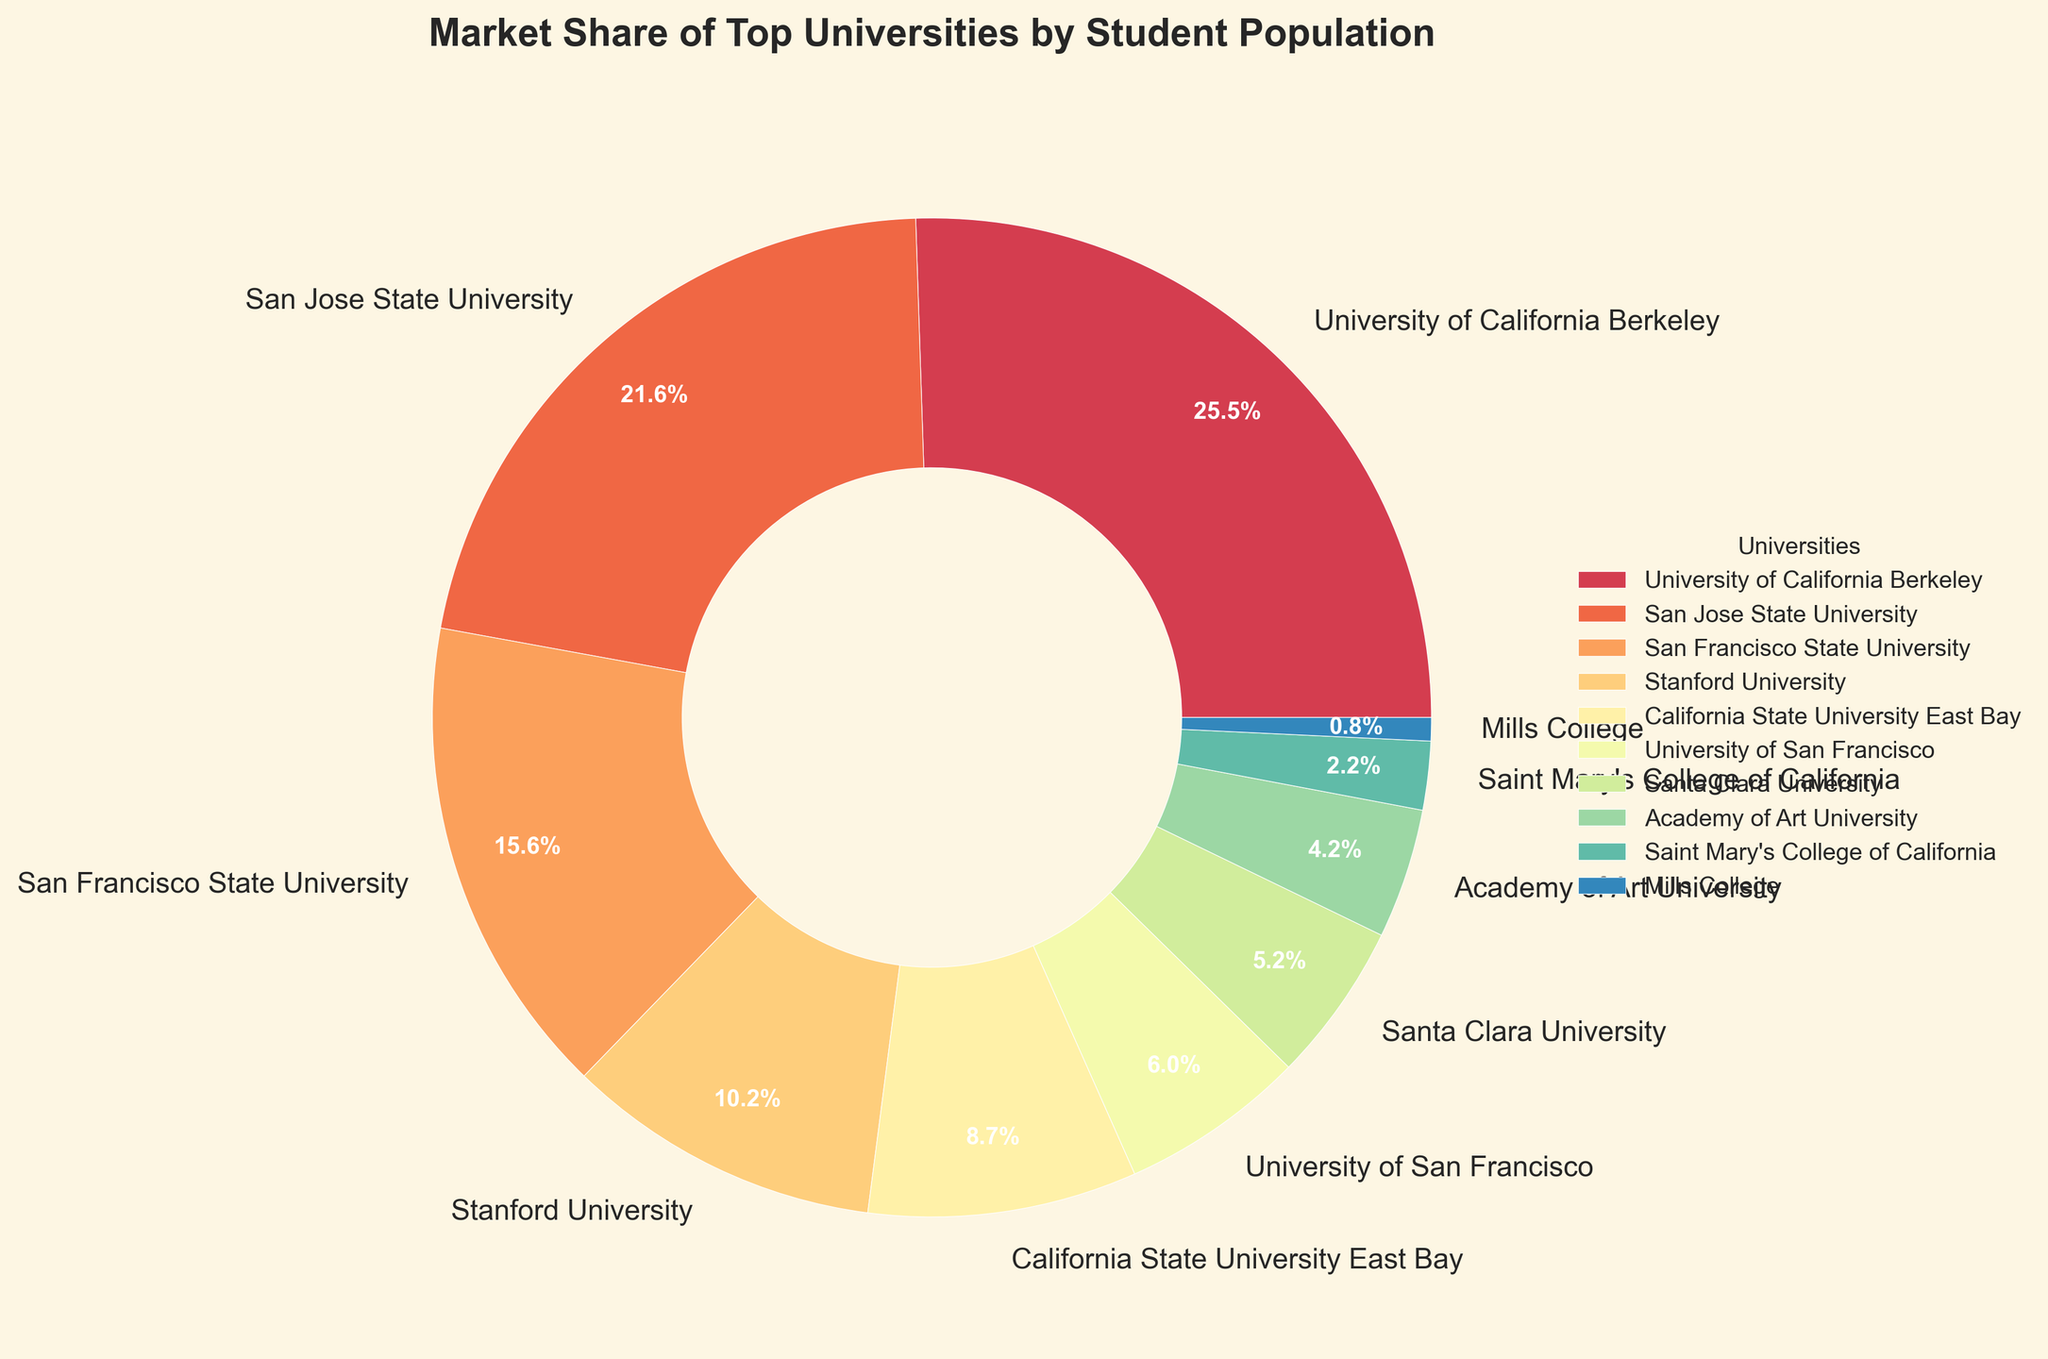What is the university with the largest market share of student population? Look at the pie chart and locate the wedge with the largest percentage. According to the chart, it is the University of California Berkeley.
Answer: University of California Berkeley Which two universities have the closest market share percentages? Examine the wedges to identify the closest percentages. The two closest percentages are California State University East Bay (8.9%) and University of San Francisco (6.1%).
Answer: California State University East Bay and University of San Francisco What is the combined market share of Stanford University and Santa Clara University? Add together the percentages for these two universities: Stanford University (12.0%) and Santa Clara University (6.0%). 12.0% + 6.0% = 18.0%.
Answer: 18.0% Which university has a larger market share, San Jose State University or San Francisco State University? Compare their percentages on the pie chart: San Jose State University (25.6%) is larger than San Francisco State University (18.5%).
Answer: San Jose State University What's the difference in market share between the University of California Berkeley and the Academy of Art University? Subtract the percentage of the Academy of Art University (5.0%) from the University of California Berkeley (30.3%): 30.3% - 5.0% = 25.3%.
Answer: 25.3% Which universities have a market share greater than 10% but less than 20%? Identify wedges with percentages within this range. Both San Jose State University (25.6%) and Stanford University (12.0%) are the only ones fitting this description.
Answer: Stanford University How many universities have a market share of less than 5%? Count the wedges with percentages less than 5%. Saint Mary's College of California (2.6%) and Mills College (0.9%).
Answer: 2 What's the average market share of the top 4 universities? Add the percentages of the top 4 universities: University of California Berkeley (30.3%), San Jose State University (25.6%), San Francisco State University (18.5%), Stanford University (12.0%); then divide by 4: (30.3% + 25.6% + 18.5% + 12.0%) / 4 = 86.4% / 4 ≈ 21.6%.
Answer: 21.6% Which university section is depicted with the darkest shade in the color spectrum? The pie chart uses a gradient of colors, and the darkest shade is typically assigned to the largest section. University of California Berkeley has the darkest shade.
Answer: University of California Berkeley What is the sum of the market shares of the three smallest universities? Add the percentages for these universities: Saint Mary's College of California (2.6%), Mills College (0.9%), and Academy of Art University (5.0%): 2.6% + 0.9% + 5.0% = 8.5%.
Answer: 8.5% 